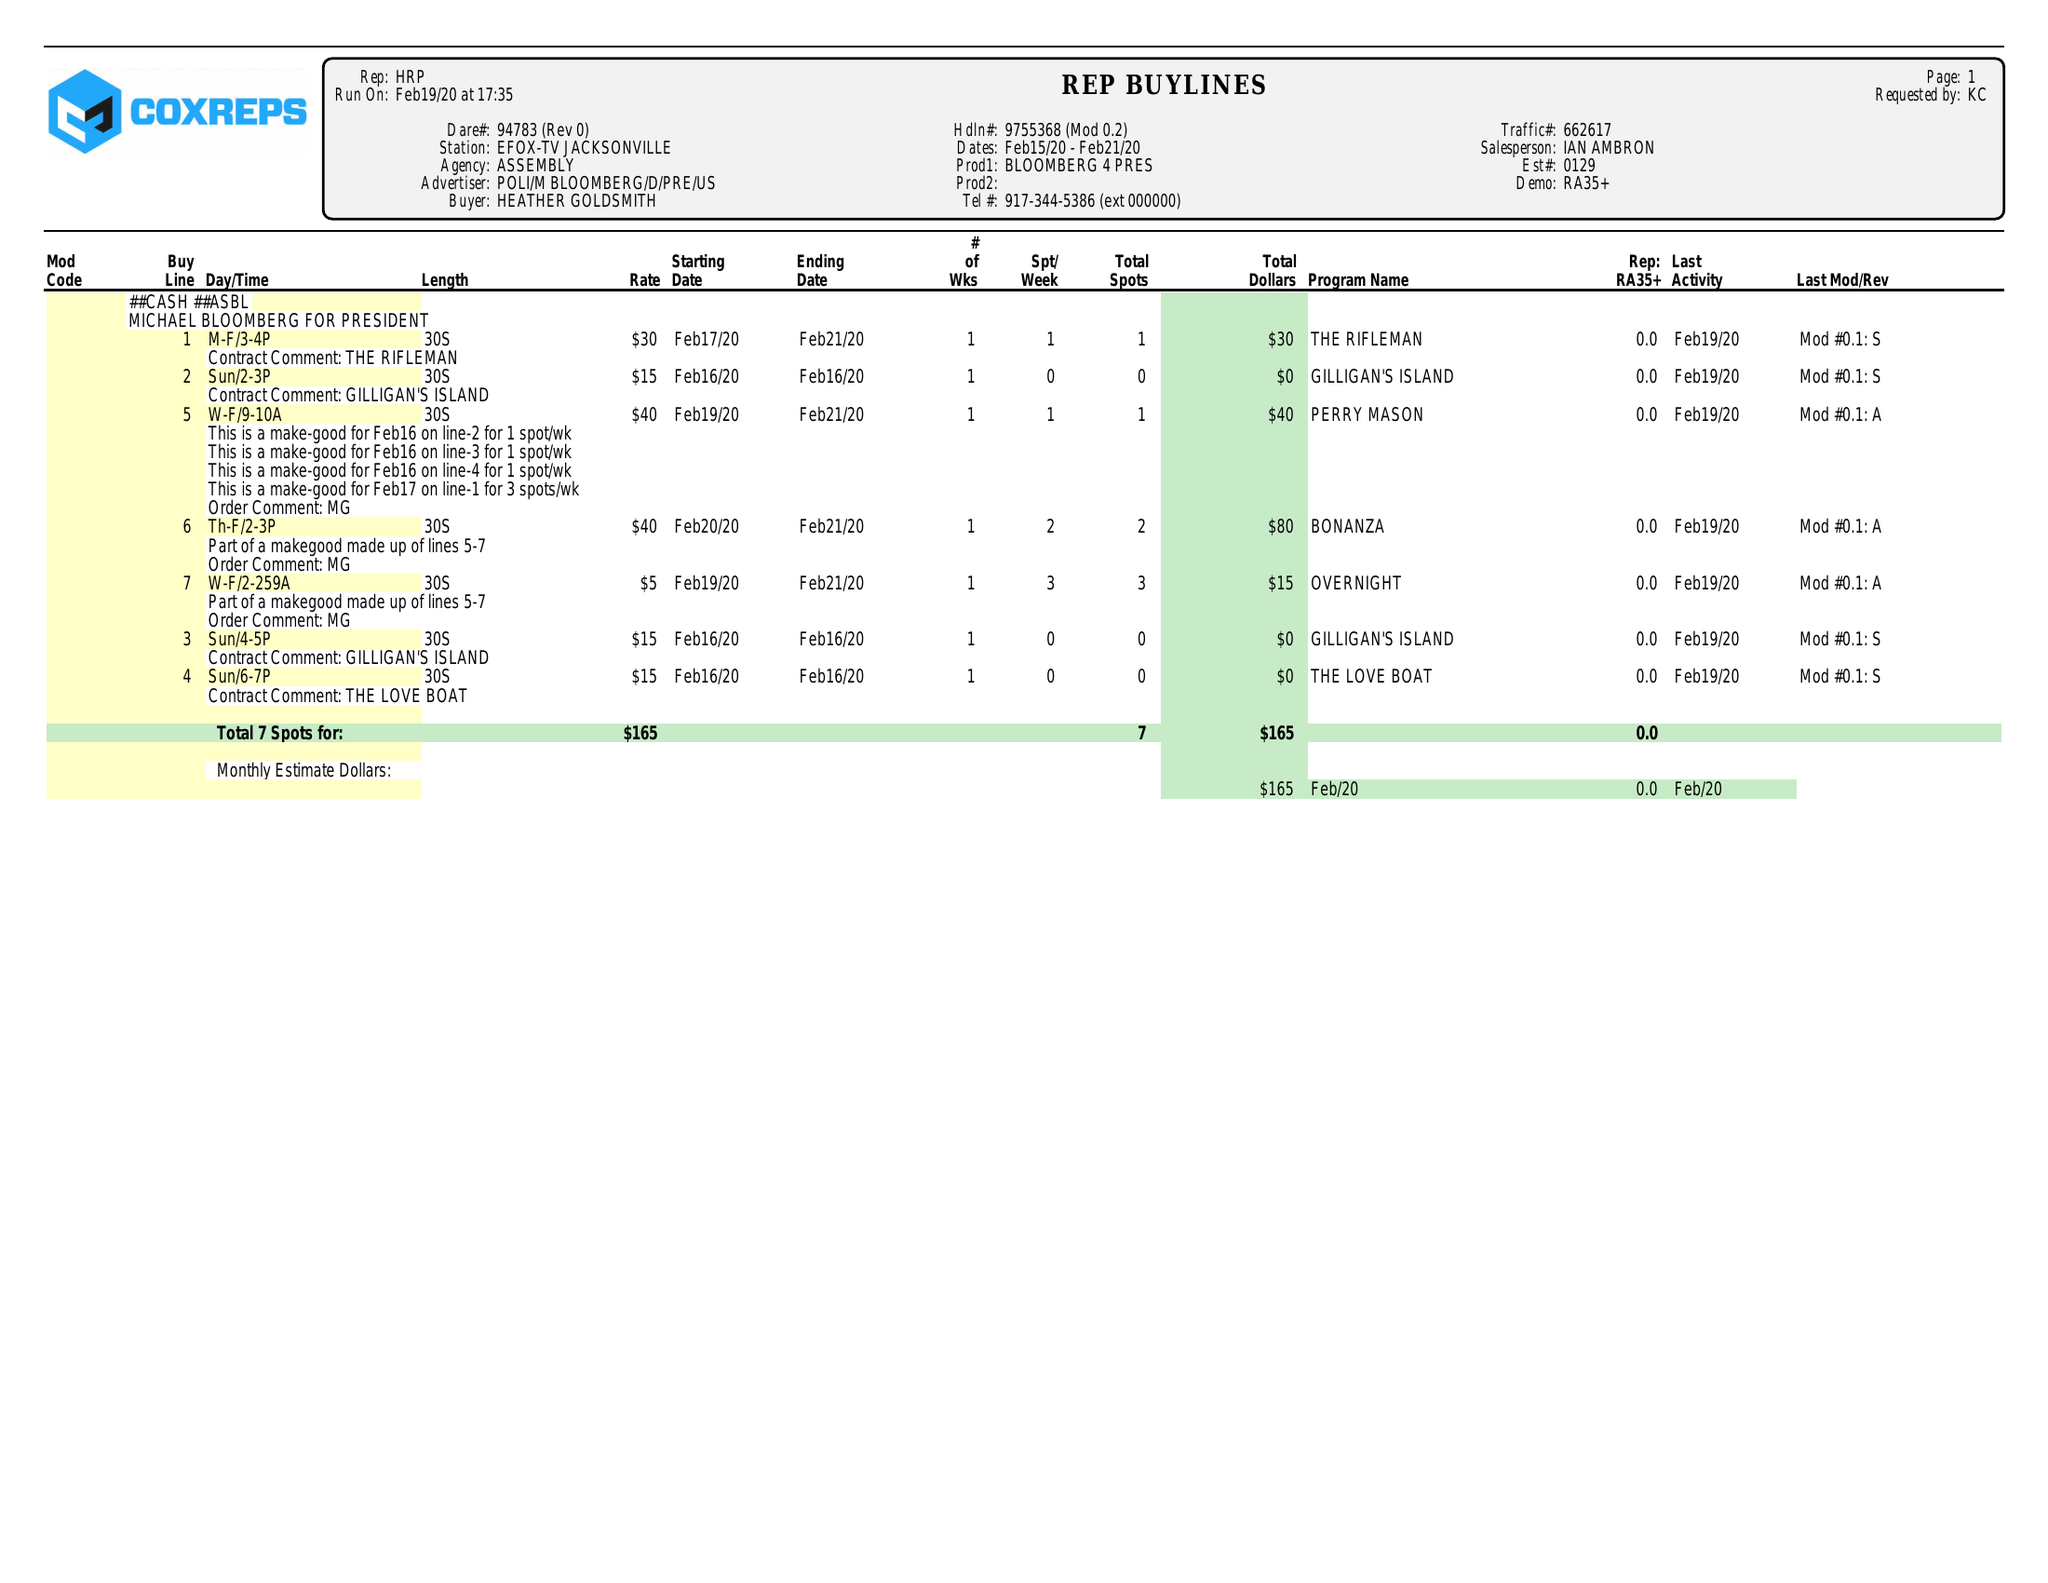What is the value for the flight_to?
Answer the question using a single word or phrase. 02/21/20 